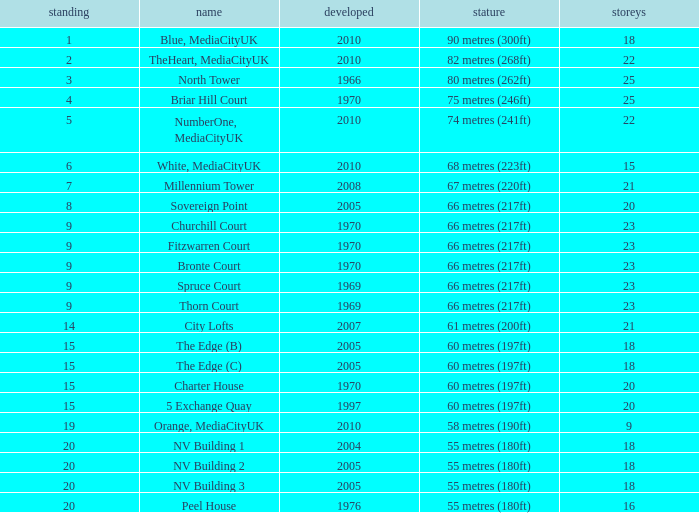What is Height, when Rank is less than 20, when Floors is greater than 9, when Built is 2005, and when Name is The Edge (C)? 60 metres (197ft). 